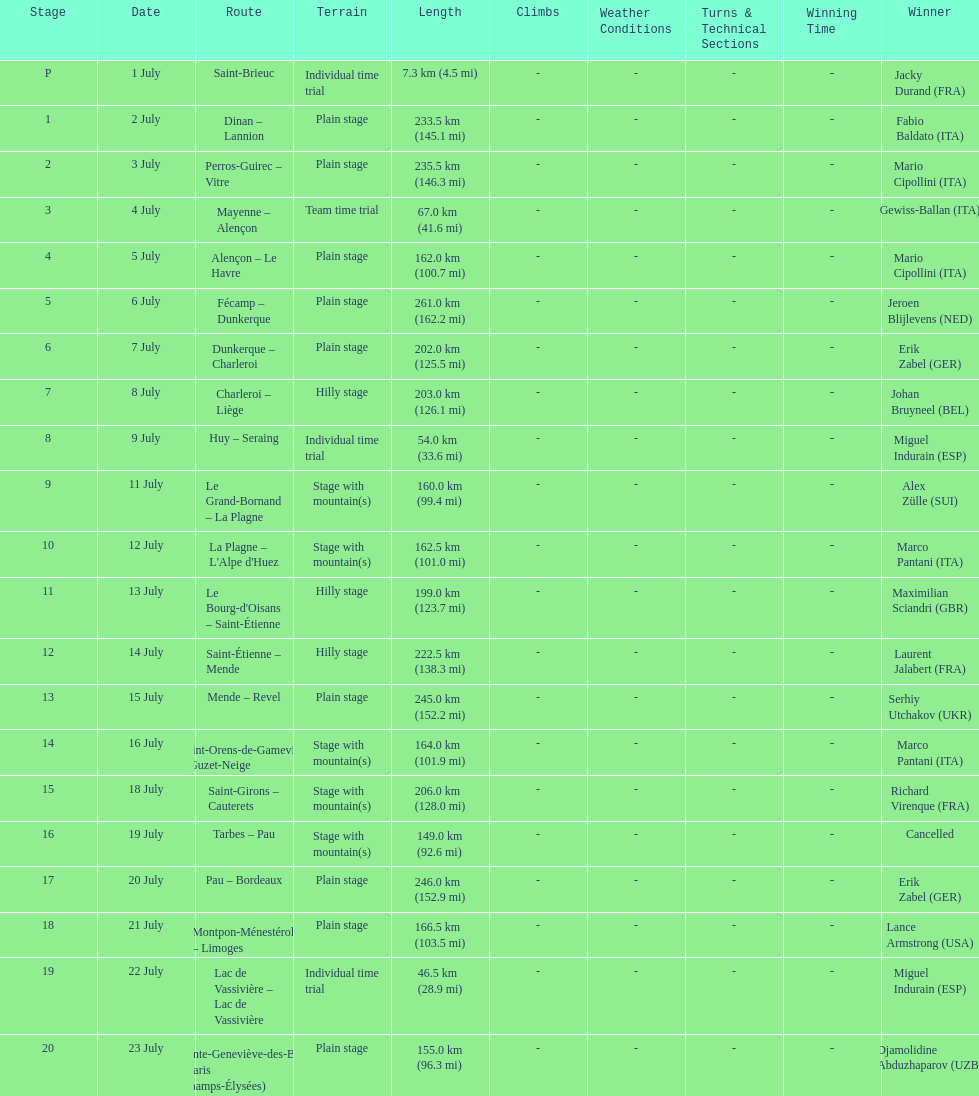How many stages were at least 200 km in length in the 1995 tour de france? 9. Write the full table. {'header': ['Stage', 'Date', 'Route', 'Terrain', 'Length', 'Climbs', 'Weather Conditions', 'Turns & Technical Sections', 'Winning Time', 'Winner'], 'rows': [['P', '1 July', 'Saint-Brieuc', 'Individual time trial', '7.3\xa0km (4.5\xa0mi)', '-', '-', '-', '-', 'Jacky Durand\xa0(FRA)'], ['1', '2 July', 'Dinan – Lannion', 'Plain stage', '233.5\xa0km (145.1\xa0mi)', '-', '-', '-', '-', 'Fabio Baldato\xa0(ITA)'], ['2', '3 July', 'Perros-Guirec – Vitre', 'Plain stage', '235.5\xa0km (146.3\xa0mi)', '-', '-', '-', '-', 'Mario Cipollini\xa0(ITA)'], ['3', '4 July', 'Mayenne – Alençon', 'Team time trial', '67.0\xa0km (41.6\xa0mi)', '-', '-', '-', '-', 'Gewiss-Ballan\xa0(ITA)'], ['4', '5 July', 'Alençon – Le Havre', 'Plain stage', '162.0\xa0km (100.7\xa0mi)', '-', '-', '-', '-', 'Mario Cipollini\xa0(ITA)'], ['5', '6 July', 'Fécamp – Dunkerque', 'Plain stage', '261.0\xa0km (162.2\xa0mi)', '-', '-', '-', '-', 'Jeroen Blijlevens\xa0(NED)'], ['6', '7 July', 'Dunkerque – Charleroi', 'Plain stage', '202.0\xa0km (125.5\xa0mi)', '-', '-', '-', '-', 'Erik Zabel\xa0(GER)'], ['7', '8 July', 'Charleroi – Liège', 'Hilly stage', '203.0\xa0km (126.1\xa0mi)', '-', '-', '-', '-', 'Johan Bruyneel\xa0(BEL)'], ['8', '9 July', 'Huy – Seraing', 'Individual time trial', '54.0\xa0km (33.6\xa0mi)', '-', '-', '-', '-', 'Miguel Indurain\xa0(ESP)'], ['9', '11 July', 'Le Grand-Bornand – La Plagne', 'Stage with mountain(s)', '160.0\xa0km (99.4\xa0mi)', '-', '-', '-', '-', 'Alex Zülle\xa0(SUI)'], ['10', '12 July', "La Plagne – L'Alpe d'Huez", 'Stage with mountain(s)', '162.5\xa0km (101.0\xa0mi)', '-', '-', '-', '-', 'Marco Pantani\xa0(ITA)'], ['11', '13 July', "Le Bourg-d'Oisans – Saint-Étienne", 'Hilly stage', '199.0\xa0km (123.7\xa0mi)', '-', '-', '-', '-', 'Maximilian Sciandri\xa0(GBR)'], ['12', '14 July', 'Saint-Étienne – Mende', 'Hilly stage', '222.5\xa0km (138.3\xa0mi)', '-', '-', '-', '-', 'Laurent Jalabert\xa0(FRA)'], ['13', '15 July', 'Mende – Revel', 'Plain stage', '245.0\xa0km (152.2\xa0mi)', '-', '-', '-', '-', 'Serhiy Utchakov\xa0(UKR)'], ['14', '16 July', 'Saint-Orens-de-Gameville – Guzet-Neige', 'Stage with mountain(s)', '164.0\xa0km (101.9\xa0mi)', '-', '-', '-', '-', 'Marco Pantani\xa0(ITA)'], ['15', '18 July', 'Saint-Girons – Cauterets', 'Stage with mountain(s)', '206.0\xa0km (128.0\xa0mi)', '-', '-', '-', '-', 'Richard Virenque\xa0(FRA)'], ['16', '19 July', 'Tarbes – Pau', 'Stage with mountain(s)', '149.0\xa0km (92.6\xa0mi)', '-', '-', '-', '-', 'Cancelled'], ['17', '20 July', 'Pau – Bordeaux', 'Plain stage', '246.0\xa0km (152.9\xa0mi)', '-', '-', '-', '-', 'Erik Zabel\xa0(GER)'], ['18', '21 July', 'Montpon-Ménestérol – Limoges', 'Plain stage', '166.5\xa0km (103.5\xa0mi)', '-', '-', '-', '-', 'Lance Armstrong\xa0(USA)'], ['19', '22 July', 'Lac de Vassivière – Lac de Vassivière', 'Individual time trial', '46.5\xa0km (28.9\xa0mi)', '-', '-', '-', '-', 'Miguel Indurain\xa0(ESP)'], ['20', '23 July', 'Sainte-Geneviève-des-Bois – Paris (Champs-Élysées)', 'Plain stage', '155.0\xa0km (96.3\xa0mi)', '-', '-', '-', '-', 'Djamolidine Abduzhaparov\xa0(UZB)']]} 